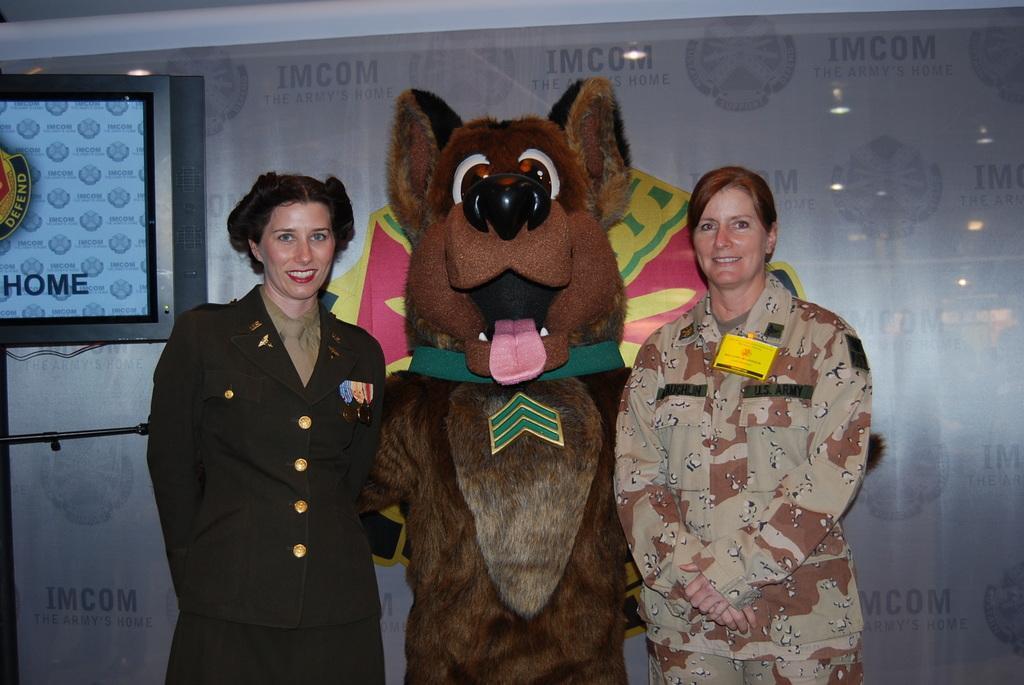In one or two sentences, can you explain what this image depicts? In this image, we can see a doll in between persons. These persons are wearing clothes. There is a screen in the top left of the image. 